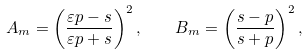<formula> <loc_0><loc_0><loc_500><loc_500>A _ { m } = \left ( \frac { \varepsilon p - s } { \varepsilon p + s } \right ) ^ { 2 } , \quad B _ { m } = \left ( \frac { s - p } { s + p } \right ) ^ { 2 } ,</formula> 